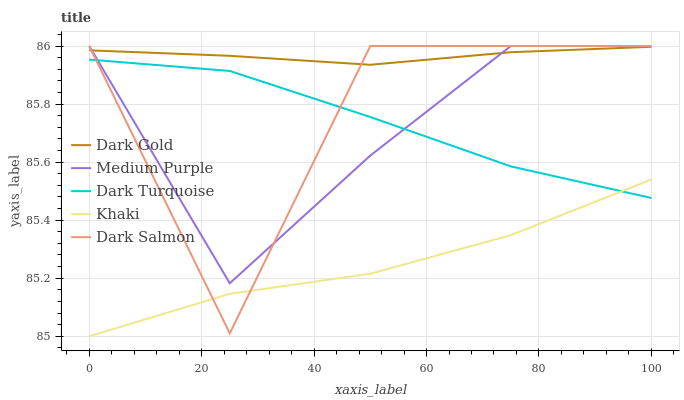Does Khaki have the minimum area under the curve?
Answer yes or no. Yes. Does Dark Gold have the maximum area under the curve?
Answer yes or no. Yes. Does Dark Turquoise have the minimum area under the curve?
Answer yes or no. No. Does Dark Turquoise have the maximum area under the curve?
Answer yes or no. No. Is Dark Gold the smoothest?
Answer yes or no. Yes. Is Dark Salmon the roughest?
Answer yes or no. Yes. Is Dark Turquoise the smoothest?
Answer yes or no. No. Is Dark Turquoise the roughest?
Answer yes or no. No. Does Khaki have the lowest value?
Answer yes or no. Yes. Does Dark Turquoise have the lowest value?
Answer yes or no. No. Does Dark Salmon have the highest value?
Answer yes or no. Yes. Does Dark Turquoise have the highest value?
Answer yes or no. No. Is Khaki less than Dark Gold?
Answer yes or no. Yes. Is Medium Purple greater than Khaki?
Answer yes or no. Yes. Does Dark Gold intersect Medium Purple?
Answer yes or no. Yes. Is Dark Gold less than Medium Purple?
Answer yes or no. No. Is Dark Gold greater than Medium Purple?
Answer yes or no. No. Does Khaki intersect Dark Gold?
Answer yes or no. No. 